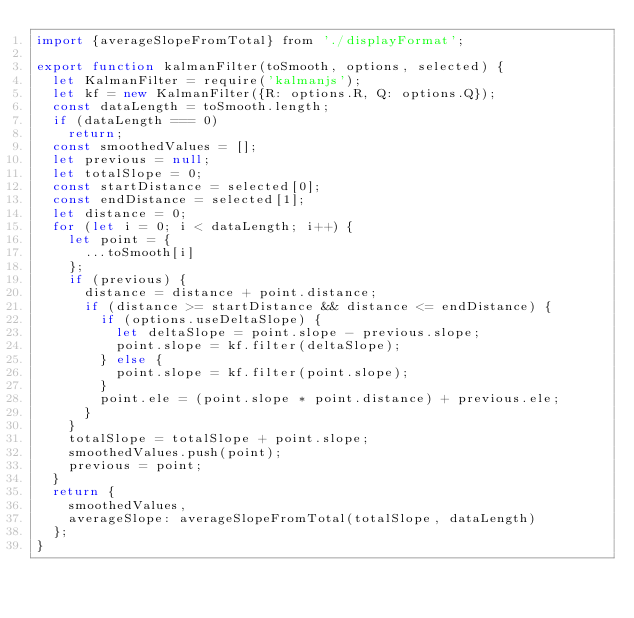Convert code to text. <code><loc_0><loc_0><loc_500><loc_500><_JavaScript_>import {averageSlopeFromTotal} from './displayFormat';

export function kalmanFilter(toSmooth, options, selected) {
  let KalmanFilter = require('kalmanjs');
  let kf = new KalmanFilter({R: options.R, Q: options.Q});
  const dataLength = toSmooth.length;
  if (dataLength === 0)
    return;
  const smoothedValues = [];
  let previous = null;
  let totalSlope = 0;
  const startDistance = selected[0];
  const endDistance = selected[1];
  let distance = 0;
  for (let i = 0; i < dataLength; i++) {
    let point = {
      ...toSmooth[i]
    };
    if (previous) {
      distance = distance + point.distance;
      if (distance >= startDistance && distance <= endDistance) {
        if (options.useDeltaSlope) {
          let deltaSlope = point.slope - previous.slope;
          point.slope = kf.filter(deltaSlope);
        } else {
          point.slope = kf.filter(point.slope);
        }
        point.ele = (point.slope * point.distance) + previous.ele;
      }
    }
    totalSlope = totalSlope + point.slope;
    smoothedValues.push(point);
    previous = point;
  }
  return {
    smoothedValues,
    averageSlope: averageSlopeFromTotal(totalSlope, dataLength)
  };
}
</code> 